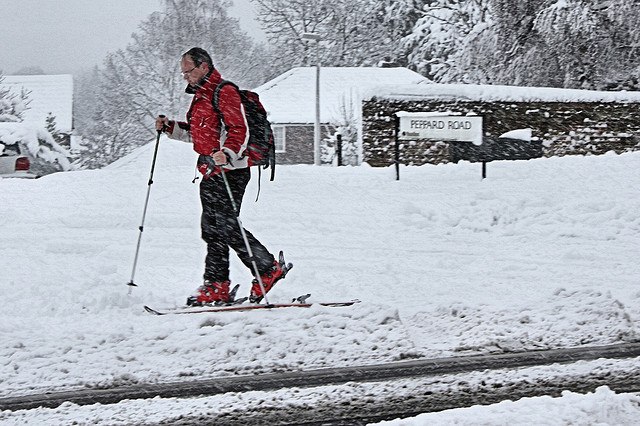Identify the text displayed in this image. PEPFARD ROAD 